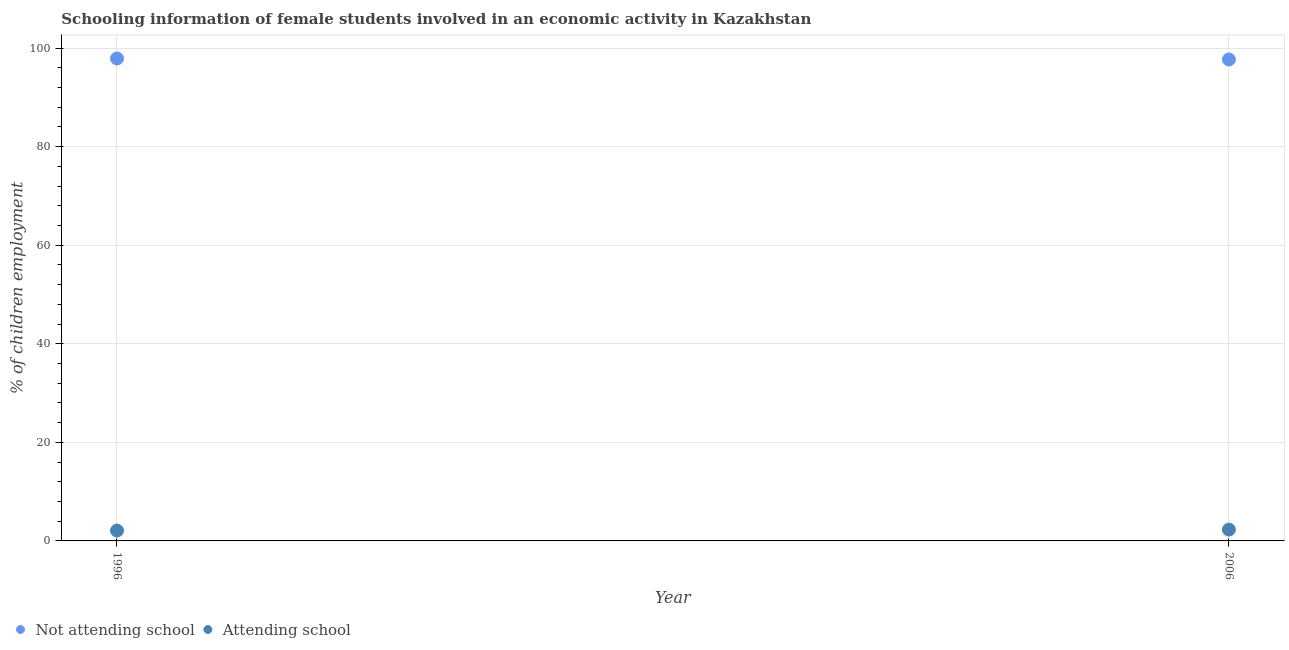How many different coloured dotlines are there?
Offer a very short reply. 2. What is the percentage of employed females who are not attending school in 2006?
Offer a very short reply. 97.7. Across all years, what is the maximum percentage of employed females who are attending school?
Ensure brevity in your answer.  2.3. Across all years, what is the minimum percentage of employed females who are not attending school?
Your response must be concise. 97.7. In which year was the percentage of employed females who are attending school maximum?
Make the answer very short. 2006. In which year was the percentage of employed females who are attending school minimum?
Make the answer very short. 1996. What is the total percentage of employed females who are not attending school in the graph?
Ensure brevity in your answer.  195.6. What is the difference between the percentage of employed females who are not attending school in 1996 and that in 2006?
Keep it short and to the point. 0.2. What is the difference between the percentage of employed females who are attending school in 2006 and the percentage of employed females who are not attending school in 1996?
Your response must be concise. -95.6. What is the average percentage of employed females who are not attending school per year?
Provide a succinct answer. 97.8. In the year 1996, what is the difference between the percentage of employed females who are not attending school and percentage of employed females who are attending school?
Provide a short and direct response. 95.8. What is the ratio of the percentage of employed females who are not attending school in 1996 to that in 2006?
Provide a succinct answer. 1. In how many years, is the percentage of employed females who are attending school greater than the average percentage of employed females who are attending school taken over all years?
Offer a very short reply. 1. Does the percentage of employed females who are not attending school monotonically increase over the years?
Provide a succinct answer. No. Is the percentage of employed females who are not attending school strictly greater than the percentage of employed females who are attending school over the years?
Offer a very short reply. Yes. How many years are there in the graph?
Provide a succinct answer. 2. Are the values on the major ticks of Y-axis written in scientific E-notation?
Give a very brief answer. No. Does the graph contain grids?
Make the answer very short. Yes. What is the title of the graph?
Offer a terse response. Schooling information of female students involved in an economic activity in Kazakhstan. Does "Merchandise exports" appear as one of the legend labels in the graph?
Make the answer very short. No. What is the label or title of the Y-axis?
Your answer should be compact. % of children employment. What is the % of children employment in Not attending school in 1996?
Offer a terse response. 97.9. What is the % of children employment in Not attending school in 2006?
Give a very brief answer. 97.7. Across all years, what is the maximum % of children employment in Not attending school?
Keep it short and to the point. 97.9. Across all years, what is the maximum % of children employment of Attending school?
Your answer should be very brief. 2.3. Across all years, what is the minimum % of children employment of Not attending school?
Provide a short and direct response. 97.7. What is the total % of children employment of Not attending school in the graph?
Offer a terse response. 195.6. What is the total % of children employment of Attending school in the graph?
Make the answer very short. 4.4. What is the difference between the % of children employment in Attending school in 1996 and that in 2006?
Your answer should be compact. -0.2. What is the difference between the % of children employment in Not attending school in 1996 and the % of children employment in Attending school in 2006?
Your answer should be compact. 95.6. What is the average % of children employment of Not attending school per year?
Your answer should be compact. 97.8. In the year 1996, what is the difference between the % of children employment in Not attending school and % of children employment in Attending school?
Ensure brevity in your answer.  95.8. In the year 2006, what is the difference between the % of children employment of Not attending school and % of children employment of Attending school?
Offer a very short reply. 95.4. What is the difference between the highest and the second highest % of children employment in Not attending school?
Provide a succinct answer. 0.2. 